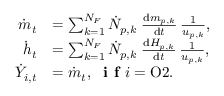<formula> <loc_0><loc_0><loc_500><loc_500>\begin{array} { r l } { \dot { m } _ { t } } & { = \sum _ { k = 1 } ^ { N _ { F } } \dot { N } _ { p , k } \, \frac { d m _ { p , k } } { d t } \, \frac { 1 } { u _ { p , k } } , } \\ { \dot { h } _ { t } } & { = \sum _ { k = 1 } ^ { N _ { F } } \dot { N } _ { p , k } \, \frac { d H _ { p , k } } { d t } \, \frac { 1 } { u _ { p , k } } , } \\ { \dot { Y } _ { i , t } } & { = \dot { m } _ { t } , \, i f i = O 2 . } \end{array}</formula> 